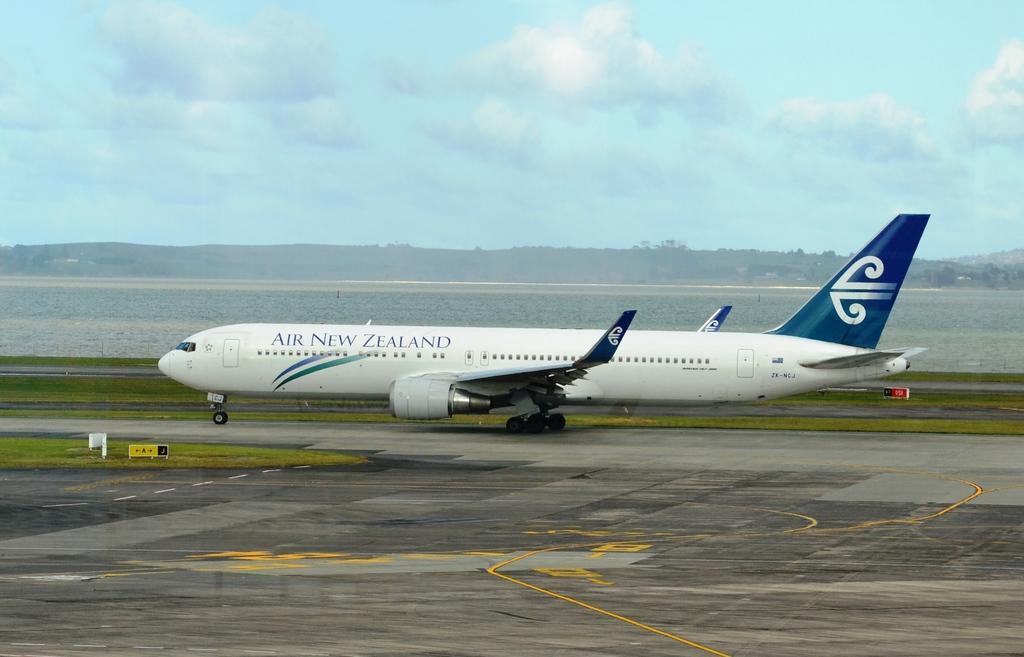In one or two sentences, can you explain what this image depicts? In the picture,the airplane is taking off from the land,it is written as "AIR NEW ZEALAND" on the plane. In the background there is sky and mountains. 